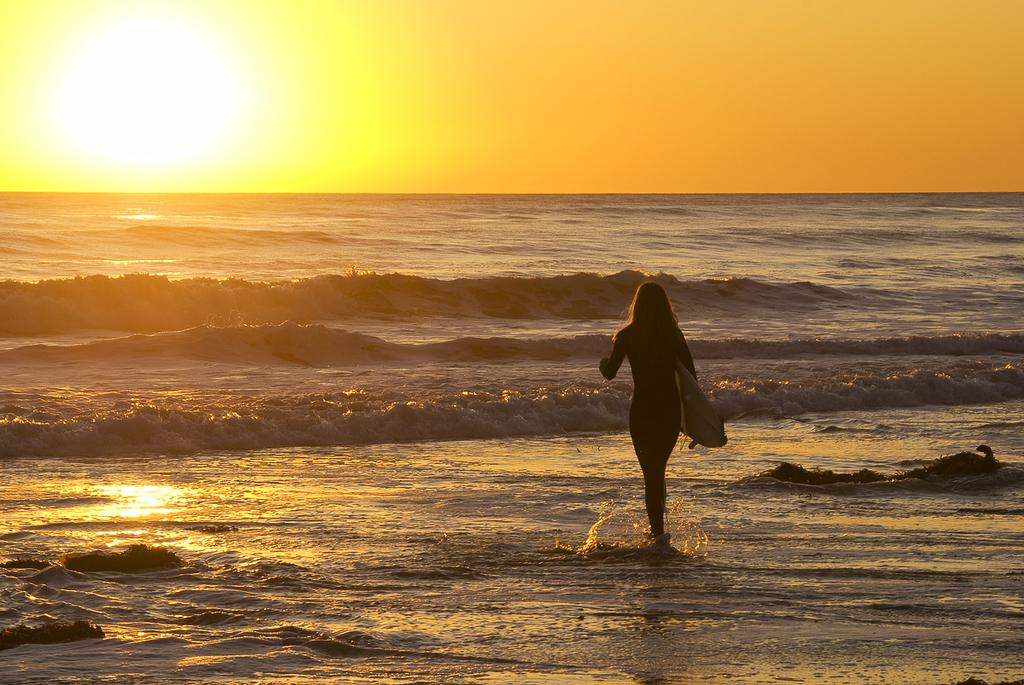What type of location is shown in the image? The image depicts a beach. What is the woman in the image doing? The woman is walking in the image. What is the woman holding while walking? The woman is holding a surfboard. What can be seen in the background of the image? The sky is visible in the background of the image. What is present at the bottom of the image? Water is present at the bottom of the image. Can you compare the woman's surfboard to a fireman's ladder in the image? There is no fireman or ladder present in the image, so a comparison cannot be made. 